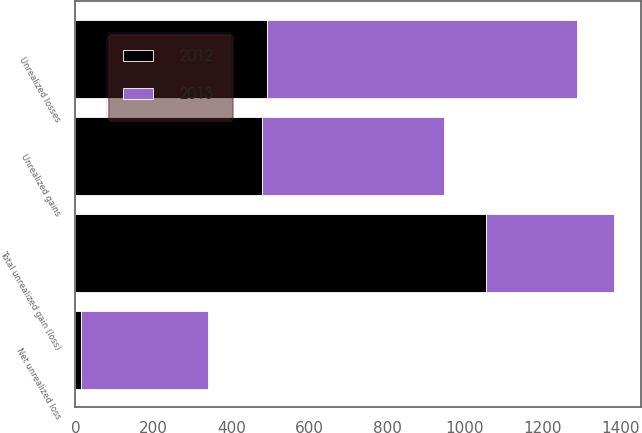Convert chart. <chart><loc_0><loc_0><loc_500><loc_500><stacked_bar_chart><ecel><fcel>Unrealized gains<fcel>Unrealized losses<fcel>Net unrealized loss<fcel>Total unrealized gain (loss)<nl><fcel>2012<fcel>478<fcel>492<fcel>14<fcel>1055<nl><fcel>2013<fcel>469<fcel>796<fcel>327<fcel>327<nl></chart> 